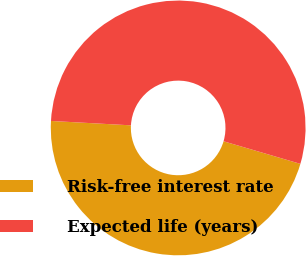<chart> <loc_0><loc_0><loc_500><loc_500><pie_chart><fcel>Risk-free interest rate<fcel>Expected life (years)<nl><fcel>46.32%<fcel>53.68%<nl></chart> 